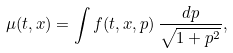Convert formula to latex. <formula><loc_0><loc_0><loc_500><loc_500>\mu ( t , x ) = \int f ( t , x , p ) \, \frac { d p } { \sqrt { 1 + p ^ { 2 } } } ,</formula> 